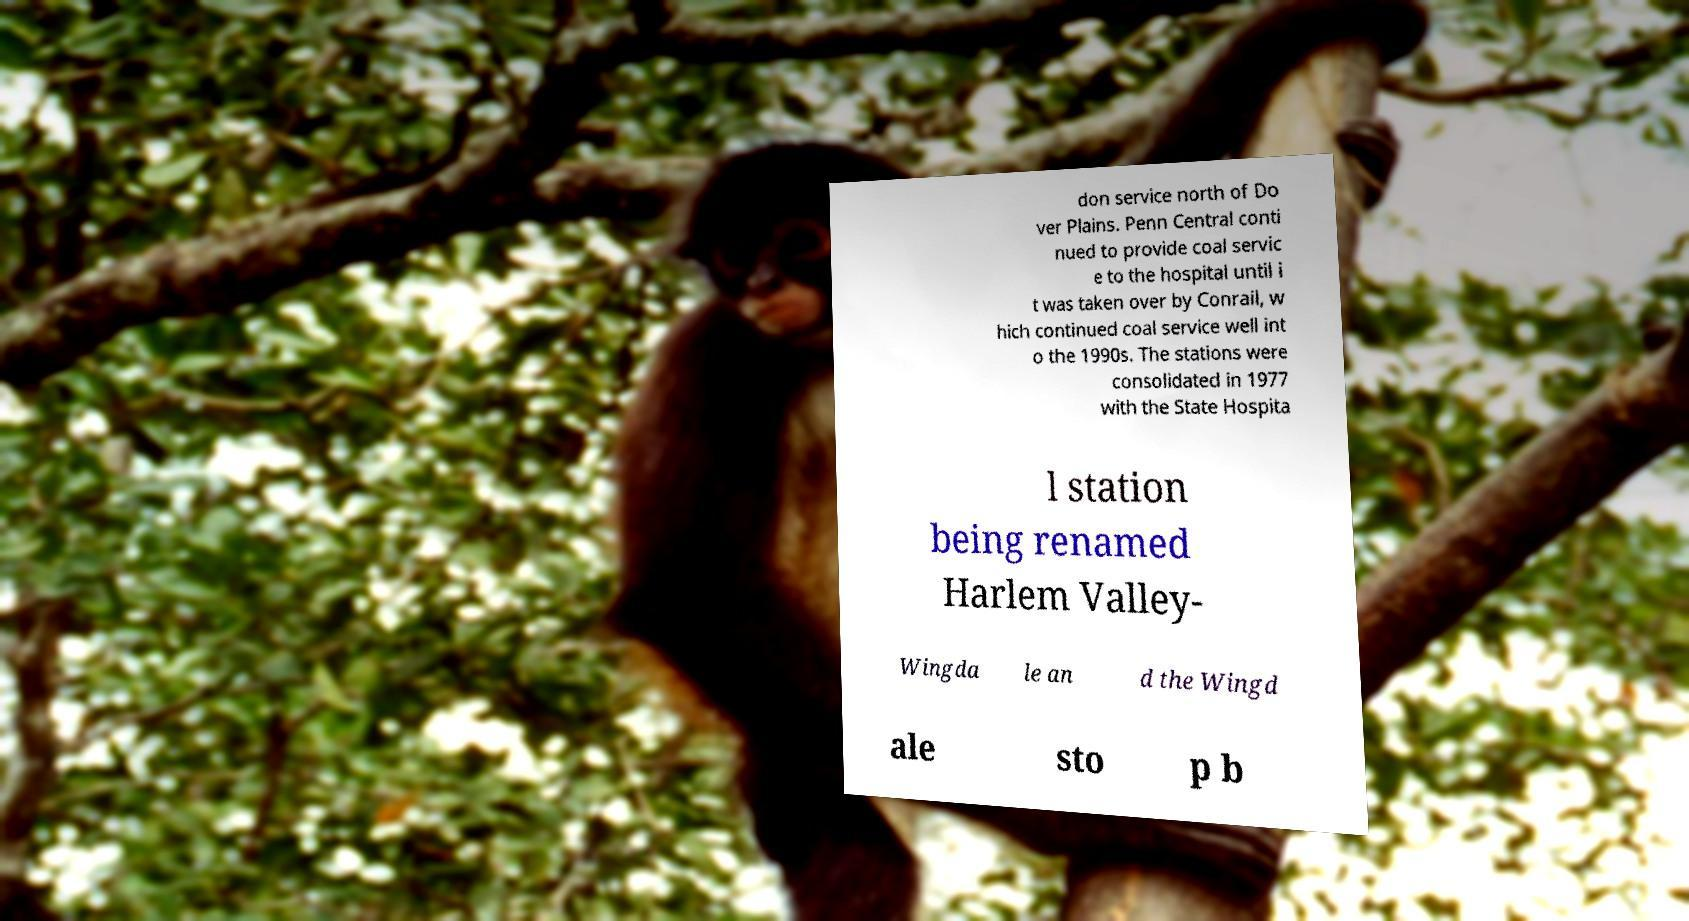There's text embedded in this image that I need extracted. Can you transcribe it verbatim? don service north of Do ver Plains. Penn Central conti nued to provide coal servic e to the hospital until i t was taken over by Conrail, w hich continued coal service well int o the 1990s. The stations were consolidated in 1977 with the State Hospita l station being renamed Harlem Valley- Wingda le an d the Wingd ale sto p b 